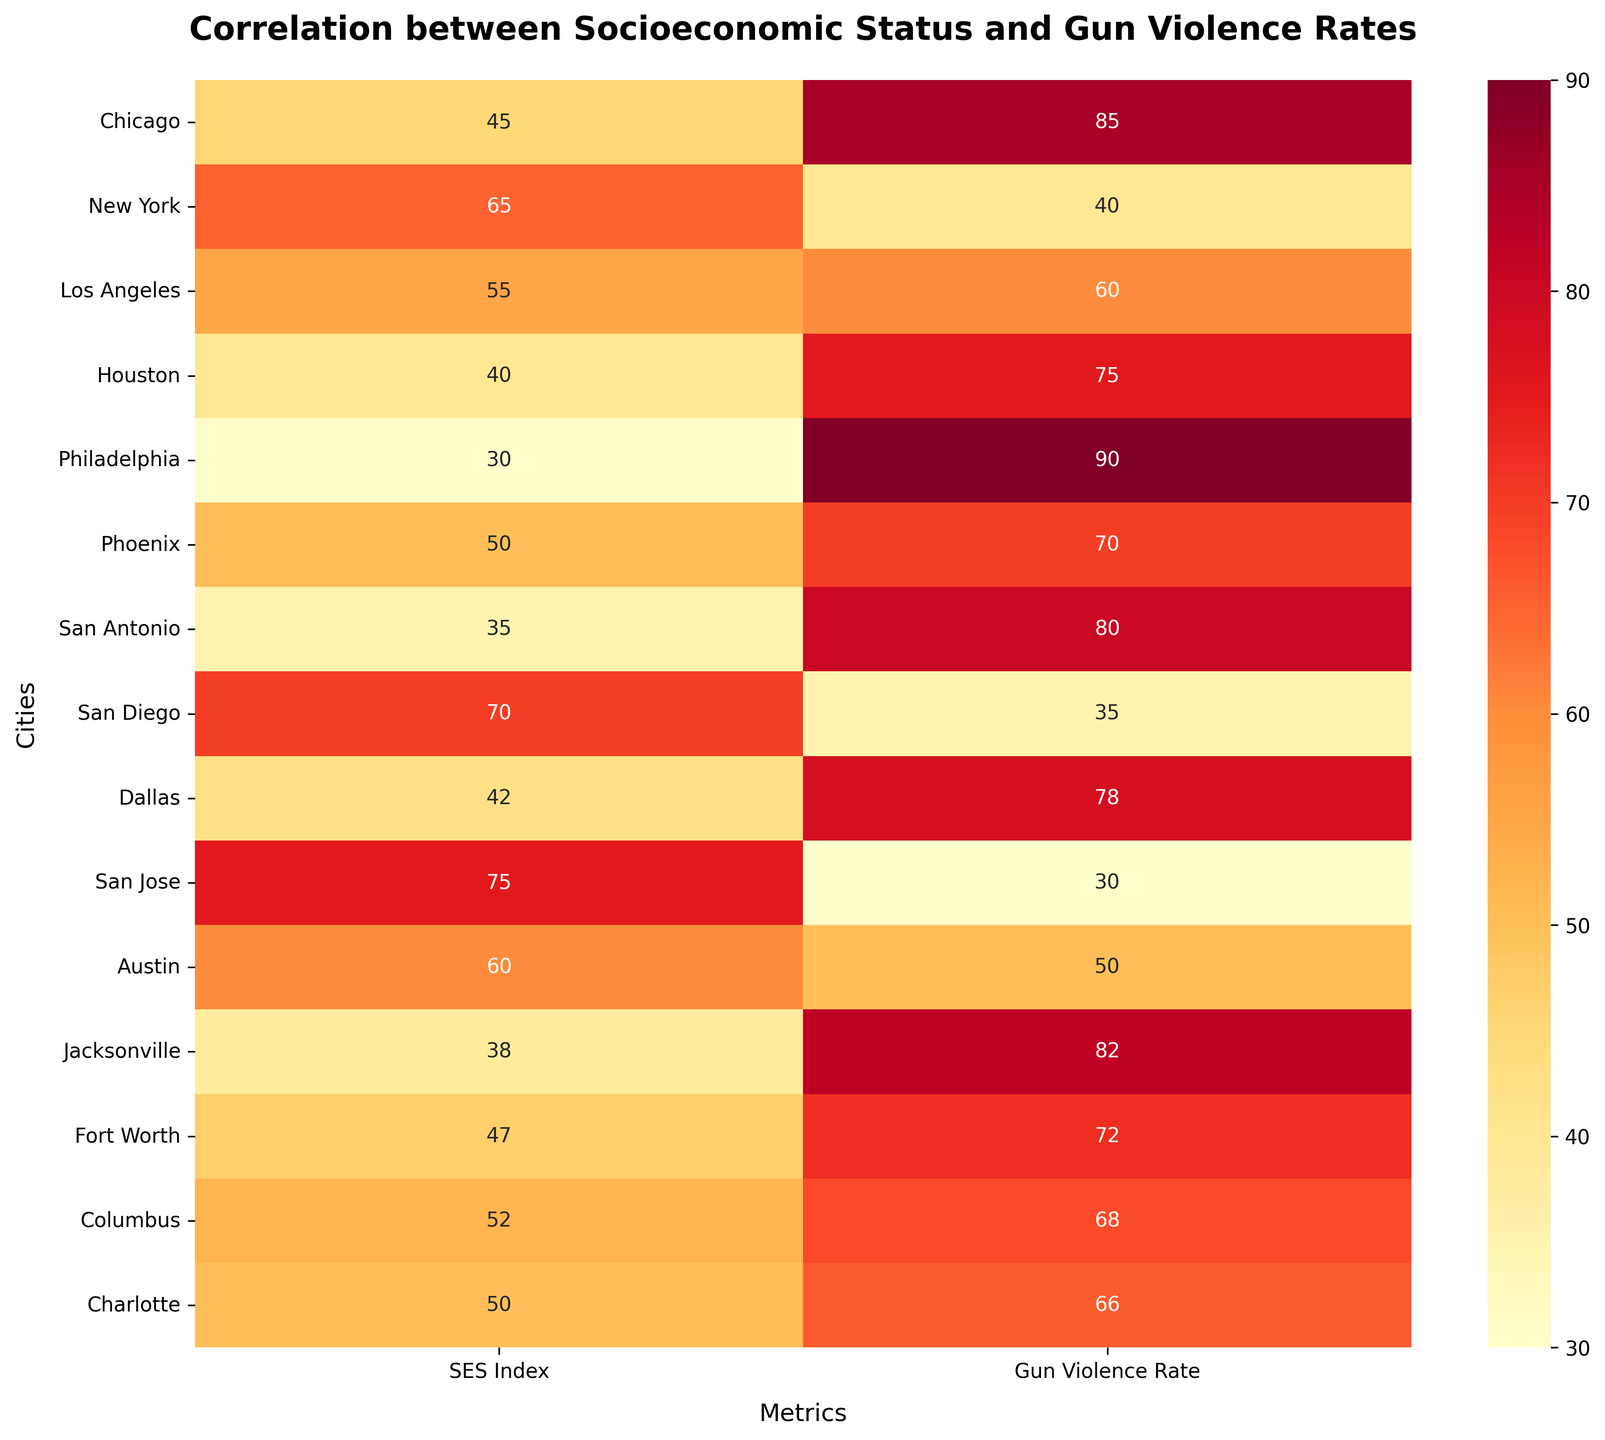What is the title of the heatmap? The title of the heatmap is displayed prominently at the top of the figure in a larger, bold font. It helps viewers understand what the heatmap is illustrating.
Answer: Correlation between Socioeconomic Status and Gun Violence Rates Which city has the highest Socioeconomic Status Index? The left column labeled "Socioeconomic Status Index" has the numbers representing the index. The highest value in this column corresponds to the highest Socioeconomic Status Index.
Answer: San Jose Which city has the highest Gun Violence Rate? The right column labeled "Gun Violence Rate" contains the numbers representing the rate. The highest value in this column is the highest Gun Violence Rate.
Answer: Philadelphia What are the Socioeconomic Status Index and Gun Violence Rate for Austin? Locate the row labeled "Austin" and read the two values from the SES Index column and the Gun Violence Rate column.
Answer: 60, 50 Which city shows the highest discrepancy between Socioeconomic Status Index and Gun Violence Rate? To find the highest discrepancy, calculate the absolute difference between the SES Index and Gun Violence Rate for each city. Identify the city with the largest difference.
Answer: Philadelphia How is the color gradient used in the heatmap to represent the data? The heatmap uses a YlOrRd (Yellow to Red) color gradient. Lighter colors represent lower values, and darker colors represent higher values. This helps to quickly visualize the distribution and intensity of the data.
Answer: Lighter to darker Which city has the closest values between Socioeconomic Status Index and Gun Violence Rate? Find the smallest absolute difference between the SES Index and Gun Violence Rate for each city and identify the city.
Answer: Charlotte What can be inferred about the relationship between Socioeconomic Status Index and Gun Violence Rate from the heatmap? Observe the patterns in the heatmap. Generally, higher SES Indexes tend to have lower Gun Violence Rates, and lower SES Indexes tend to have higher Gun Violence Rates, indicating an inverse relationship.
Answer: Inverse relationship What are the Socioeconomic Status Index and Gun Violence Rate for the city with the lowest Gun Violence Rate? Identify the city with the lowest value in the Gun Violence Rate column and read the corresponding values from both columns.
Answer: San Jose, 75, 30 Compare the Gun Violence Rate of Los Angeles and San Diego. Which city has a higher rate? Locate the rows labeled "Los Angeles" and "San Diego" and compare the numbers in the Gun Violence Rate column.
Answer: Los Angeles 